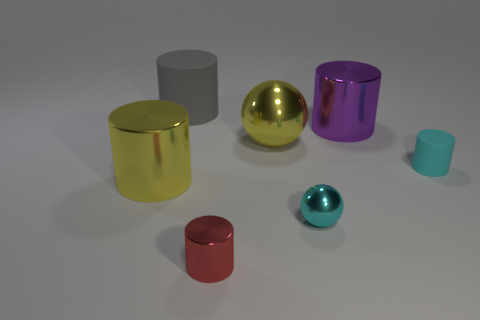Subtract all large gray cylinders. How many cylinders are left? 4 Add 1 cyan shiny spheres. How many objects exist? 8 Subtract 2 cylinders. How many cylinders are left? 3 Subtract all spheres. How many objects are left? 5 Add 2 small cyan objects. How many small cyan objects exist? 4 Subtract all cyan spheres. How many spheres are left? 1 Subtract 0 gray spheres. How many objects are left? 7 Subtract all cyan cylinders. Subtract all yellow balls. How many cylinders are left? 4 Subtract all large gray matte cylinders. Subtract all large purple objects. How many objects are left? 5 Add 4 small metallic balls. How many small metallic balls are left? 5 